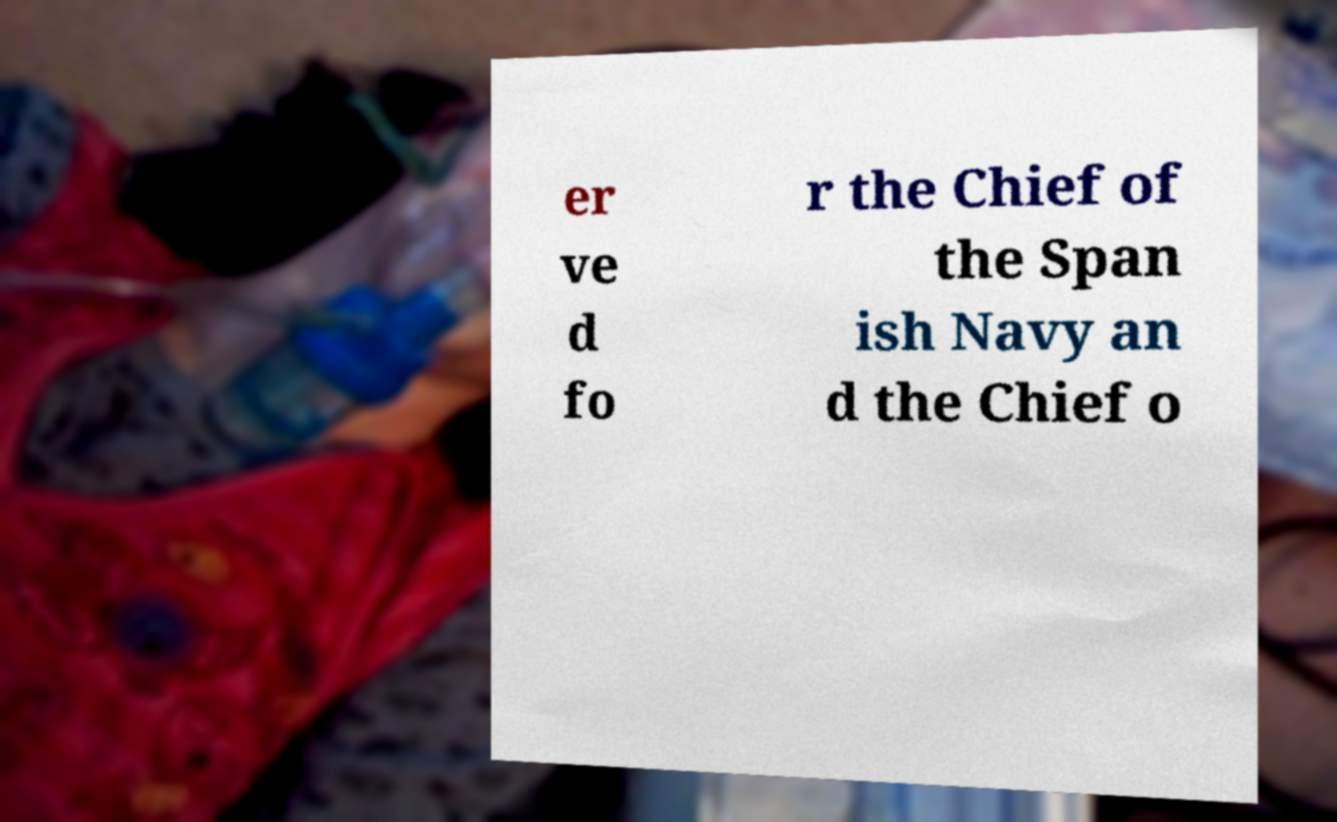Can you read and provide the text displayed in the image?This photo seems to have some interesting text. Can you extract and type it out for me? er ve d fo r the Chief of the Span ish Navy an d the Chief o 